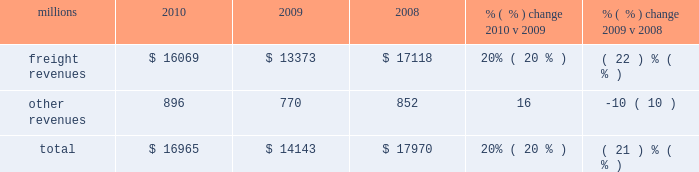Us in a position to handle demand changes .
We will also continue utilizing industrial engineering techniques to improve productivity .
2022 fuel prices 2013 uncertainty about the economy makes fuel price projections difficult , and we could see volatile fuel prices during the year , as they are sensitive to global and u.s .
Domestic demand , refining capacity , geopolitical events , weather conditions and other factors .
To reduce the impact of fuel price on earnings , we will continue to seek recovery from our customers through our fuel surcharge programs and to expand our fuel conservation efforts .
2022 capital plan 2013 in 2011 , we plan to make total capital investments of approximately $ 3.2 billion , including expenditures for positive train control ( ptc ) , which may be revised if business conditions warrant or if new laws or regulations affect our ability to generate sufficient returns on these investments .
( see further discussion in this item 7 under liquidity and capital resources 2013 capital plan. ) 2022 positive train control 2013 in response to a legislative mandate to implement ptc by the end of 2015 , we expect to spend approximately $ 250 million during 2011 on developing ptc .
We currently estimate that ptc will cost us approximately $ 1.4 billion to implement by the end of 2015 , in accordance with rules issued by the federal railroad administration ( fra ) .
This includes costs for installing the new system along our tracks , upgrading locomotives to work with the new system , and adding digital data communication equipment so all the parts of the system can communicate with each other .
During 2011 , we plan to begin testing the technology to evaluate its effectiveness .
2022 financial expectations 2013 we remain cautious about economic conditions , but anticipate volume to increase from 2010 levels .
In addition , we expect volume , price , and productivity gains to offset expected higher costs for fuel , labor inflation , depreciation , casualty costs , and property taxes to drive operating ratio improvement .
Results of operations operating revenues millions 2010 2009 2008 % (  % ) change 2010 v 2009 % (  % ) change 2009 v 2008 .
Freight revenues are revenues generated by transporting freight or other materials from our six commodity groups .
Freight revenues vary with volume ( carloads ) and average revenue per car ( arc ) .
Changes in price , traffic mix and fuel surcharges drive arc .
We provide some of our customers with contractual incentives for meeting or exceeding specified cumulative volumes or shipping to and from specific locations , which we record as a reduction to freight revenues based on the actual or projected future shipments .
We recognize freight revenues as freight moves from origin to destination .
We allocate freight revenues between reporting periods based on the relative transit time in each reporting period and recognize expenses as we incur them .
Other revenues include revenues earned by our subsidiaries , revenues from our commuter rail operations , and accessorial revenues , which we earn when customers retain equipment owned or controlled by us or when we perform additional services such as switching or storage .
We recognize other revenues as we perform services or meet contractual obligations .
Freight revenues and volume levels for all six commodity groups increased during 2010 as a result of economic improvement in many market sectors .
We experienced particularly strong volume growth in automotive , intermodal , and industrial products shipments .
Core pricing gains and higher fuel surcharges also increased freight revenues and drove a 6% ( 6 % ) improvement in arc .
Freight revenues and volume levels for all six commodity groups decreased during 2009 , reflecting continued economic weakness .
We experienced the largest volume declines in automotive and industrial .
What is the percent change in freight revenue from 2008 to 2010? 
Computations: (((17118 - 16069) / 17118) * 100)
Answer: 6.12805. 